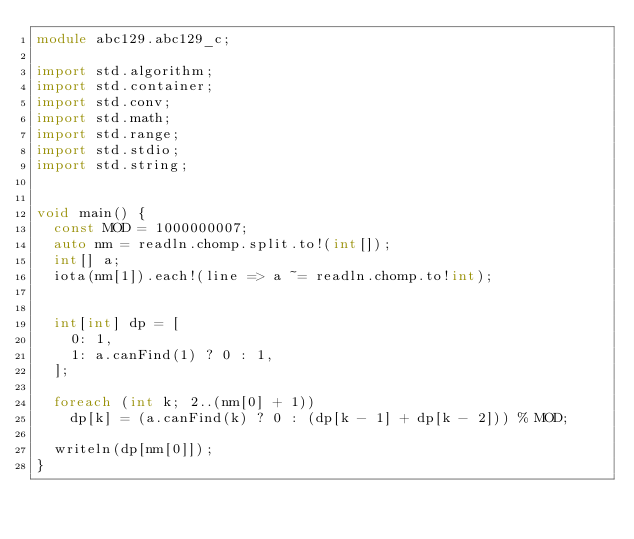<code> <loc_0><loc_0><loc_500><loc_500><_D_>module abc129.abc129_c;

import std.algorithm;
import std.container;
import std.conv;
import std.math;
import std.range;
import std.stdio;
import std.string;


void main() {
  const MOD = 1000000007;
  auto nm = readln.chomp.split.to!(int[]);
  int[] a;
  iota(nm[1]).each!(line => a ~= readln.chomp.to!int);


  int[int] dp = [
    0: 1,
    1: a.canFind(1) ? 0 : 1,
  ];

  foreach (int k; 2..(nm[0] + 1))
    dp[k] = (a.canFind(k) ? 0 : (dp[k - 1] + dp[k - 2])) % MOD;
  
  writeln(dp[nm[0]]);
}
</code> 